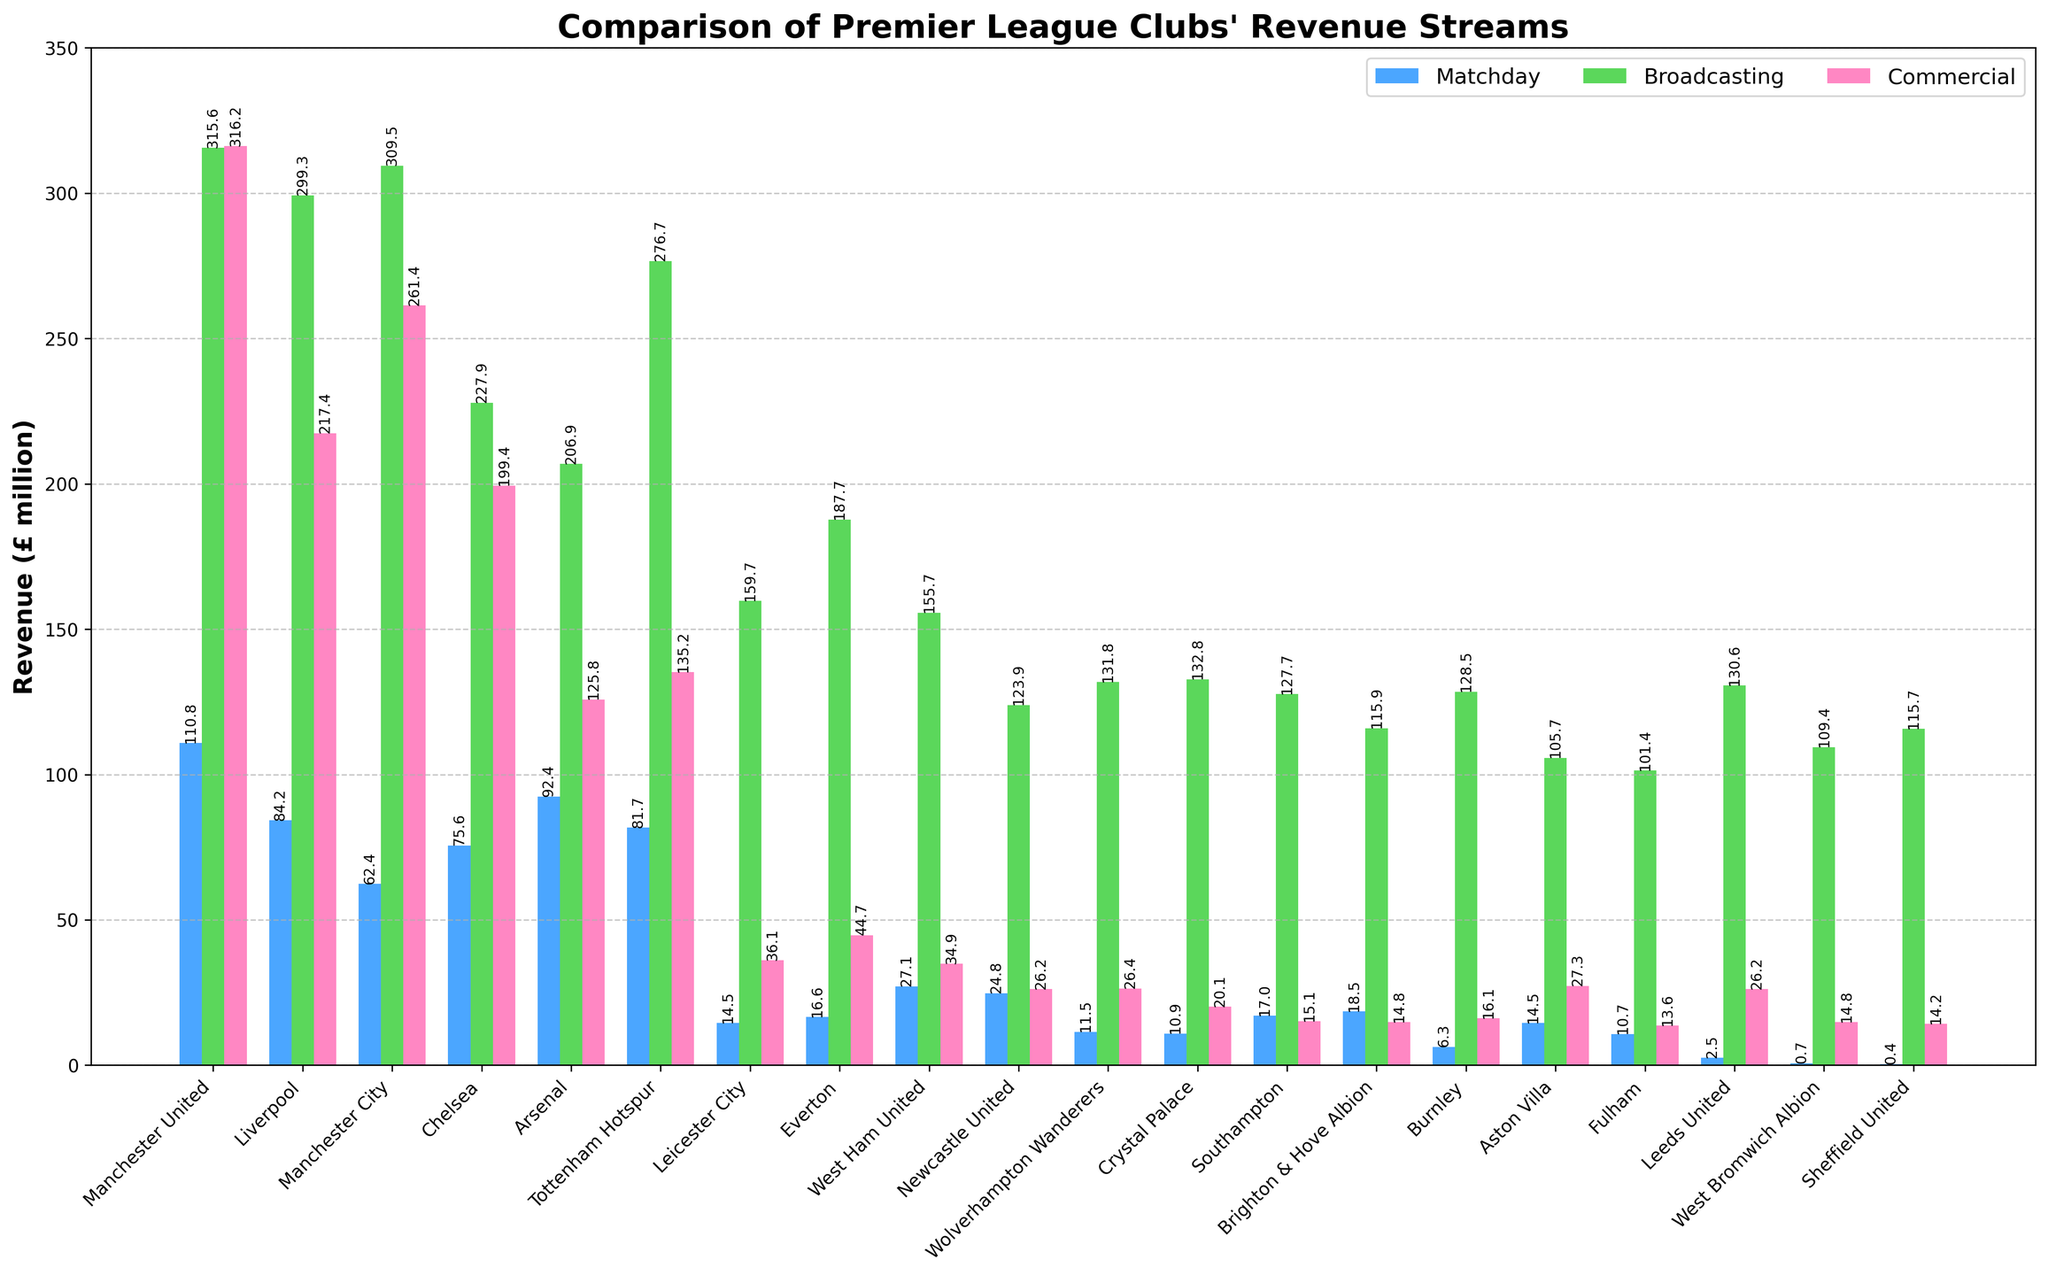Which club has the highest matchday revenue? By looking at the height of the blue bars representing matchday revenue, the tallest blue bar corresponds to Manchester United.
Answer: Manchester United Which three clubs have the lowest broadcasting revenue? By observing the green bars and their heights, the shortest green bars correspond to Sheffield United, Fulham, and West Bromwich Albion.
Answer: Sheffield United, Fulham, West Bromwich Albion What is the difference in commercial revenue between Manchester United and Liverpool? Subtract Liverpool's commercial revenue (217.4) from Manchester United's commercial revenue (316.2). 316.2 - 217.4 = 98.8
Answer: 98.8 Which club has the smallest total revenue across all three streams? Total revenue is the sum of matchday, broadcasting, and commercial revenues. Sum these for each club and identify the smallest total, which is Sheffield United (0.4+115.7+14.2=130.3).
Answer: Sheffield United How does Tottenham Hotspur's matchday revenue compare to Arsenal's matchday revenue? Compare the height of the blue bars for Tottenham Hotspur and Arsenal. Arsenal's blue bar is taller than Tottenham Hotspur's.
Answer: Arsenal's matchday revenue is higher What is the combined broadcasting revenue of the top 2 clubs? Identify the two clubs with the highest green bars, Manchester United (315.6) and Manchester City (309.5), then sum their broadcasting revenue. 315.6 + 309.5 = 625.1
Answer: 625.1 Which revenue stream contributes the most for Wolverhampton Wanderers? Observe the relative heights of the blue, green, and pink bars for Wolverhampton Wanderers. The green bar (broadcasting) is the tallest, indicating broadcasting contributes the most.
Answer: Broadcasting What is the average commercial revenue for the clubs? Sum all commercial revenues and divide by the number of clubs. (316.2+217.4+261.4+199.4+125.8+135.2+36.1+44.7+34.9+26.2+26.4+20.1+15.1+14.8+16.1+27.3+13.6+14.8+14.2)/20 = 1509.7/20 = 75.5
Answer: 75.5 Which club has the highest revenue from all three streams combined? Add up matchday, broadcasting, and commercial revenues for each club and compare. The highest total is for Manchester United (110.8 + 315.6 + 316.2 = 742.6).
Answer: Manchester United Which clubs have broadcasting revenue that is more than twice their matchday revenue? For each club, check if the broadcasting revenue is more than double the matchday revenue. This is true for Leicester City, Everton, Aston Villa, and several others.
Answer: Leicester City, Everton, Aston Villa, Sheffield United, Fulham, West Bromwich Albion 